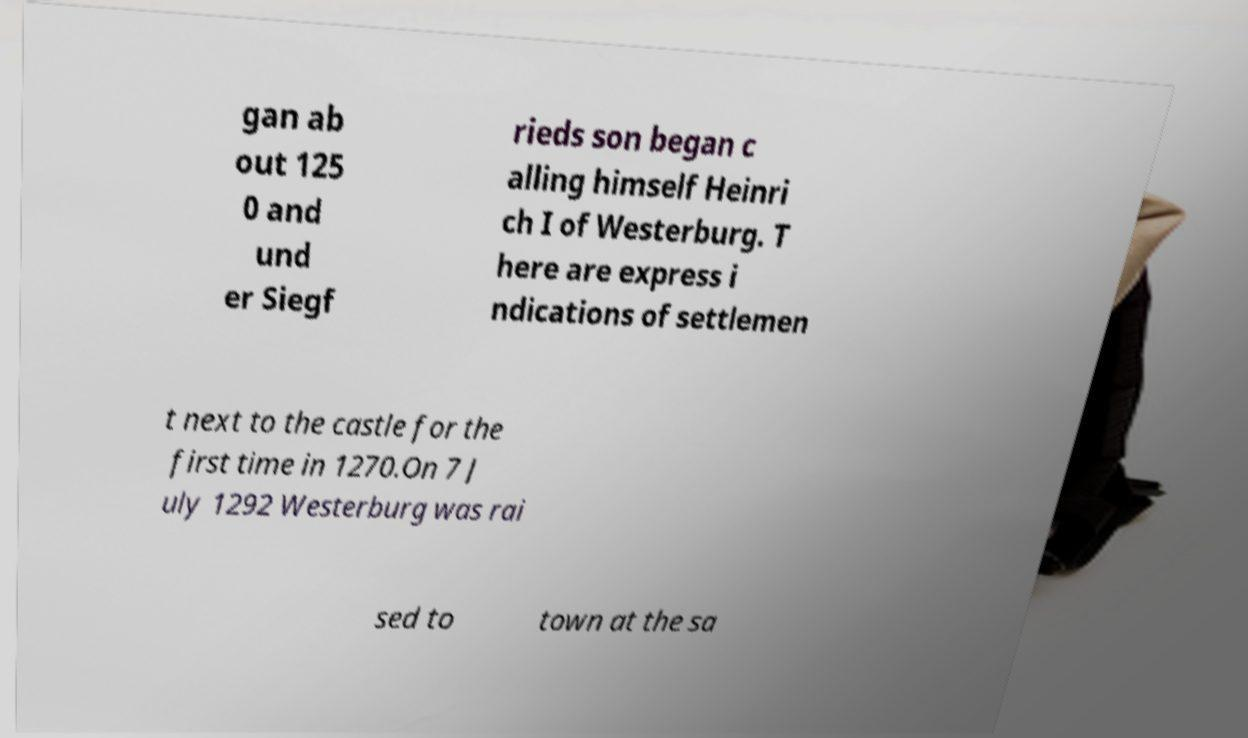Can you accurately transcribe the text from the provided image for me? gan ab out 125 0 and und er Siegf rieds son began c alling himself Heinri ch I of Westerburg. T here are express i ndications of settlemen t next to the castle for the first time in 1270.On 7 J uly 1292 Westerburg was rai sed to town at the sa 